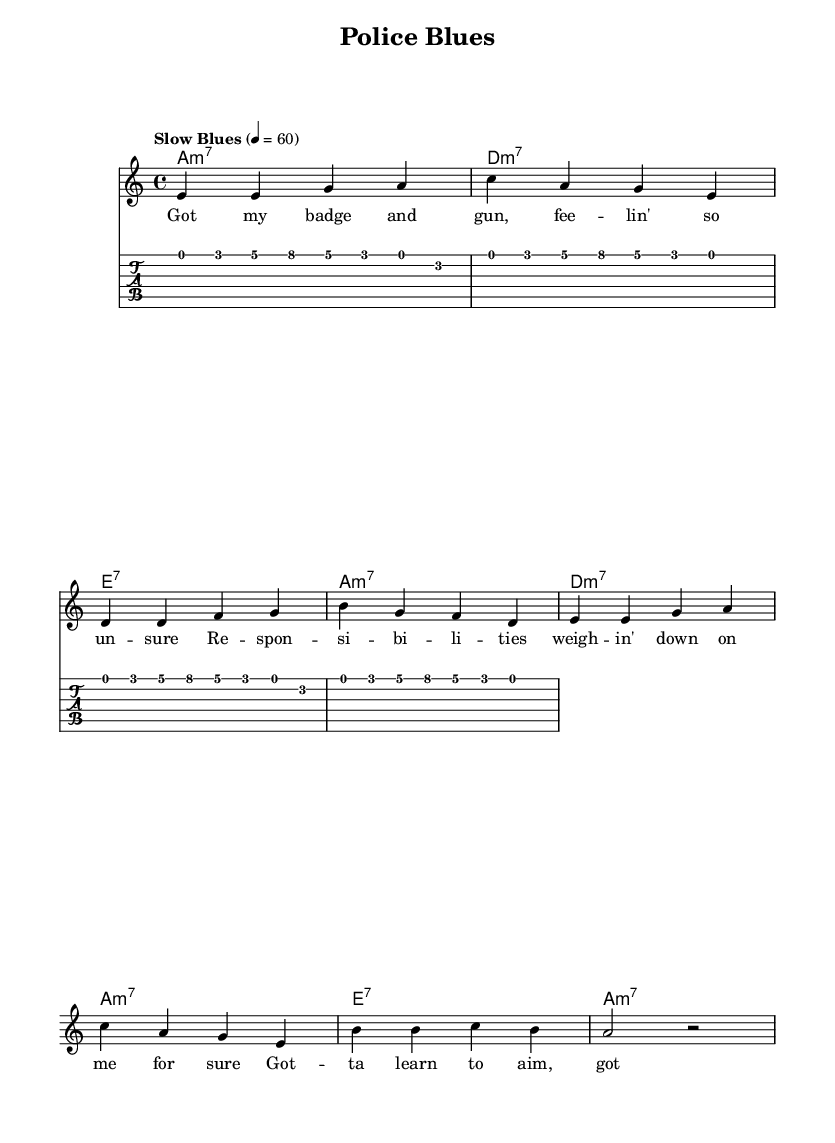What is the key signature of this music? The key signature is indicated by the presence of A minor, which has no sharps or flats.
Answer: A minor What is the time signature of the piece? The time signature is displayed at the beginning and is notated as 4 over 4, which means there are 4 beats in each measure and a quarter note gets one beat.
Answer: 4/4 What is the tempo marking for this piece? The tempo marking is written as "Slow Blues" with a metronome marking of quarter note equals 60, indicating a slow pace suitable for blues music.
Answer: Slow Blues How many measures are in the melody section? By counting the measures in the melody line, there are eight distinct measures in this melody section.
Answer: Eight What type of chords are used throughout the piece? The piece employs minor seventh and dominant seventh chords, as shown in the chord names and their associations with the melody.
Answer: Minor seventh and dominant seventh How does the guitar riff relate to the melody? The guitar riff is structured with eighth notes that outline the same motif of the melody but uses a rhythmic pattern to create a driving force typical in blues music.
Answer: Rhythmic motif What emotional theme does the lyrics suggest about law enforcement? The lyrics express feelings of uncertainty and the weight of responsibilities, illustrating the emotional challenges faced by law enforcement officers.
Answer: Uncertainty and responsibility 